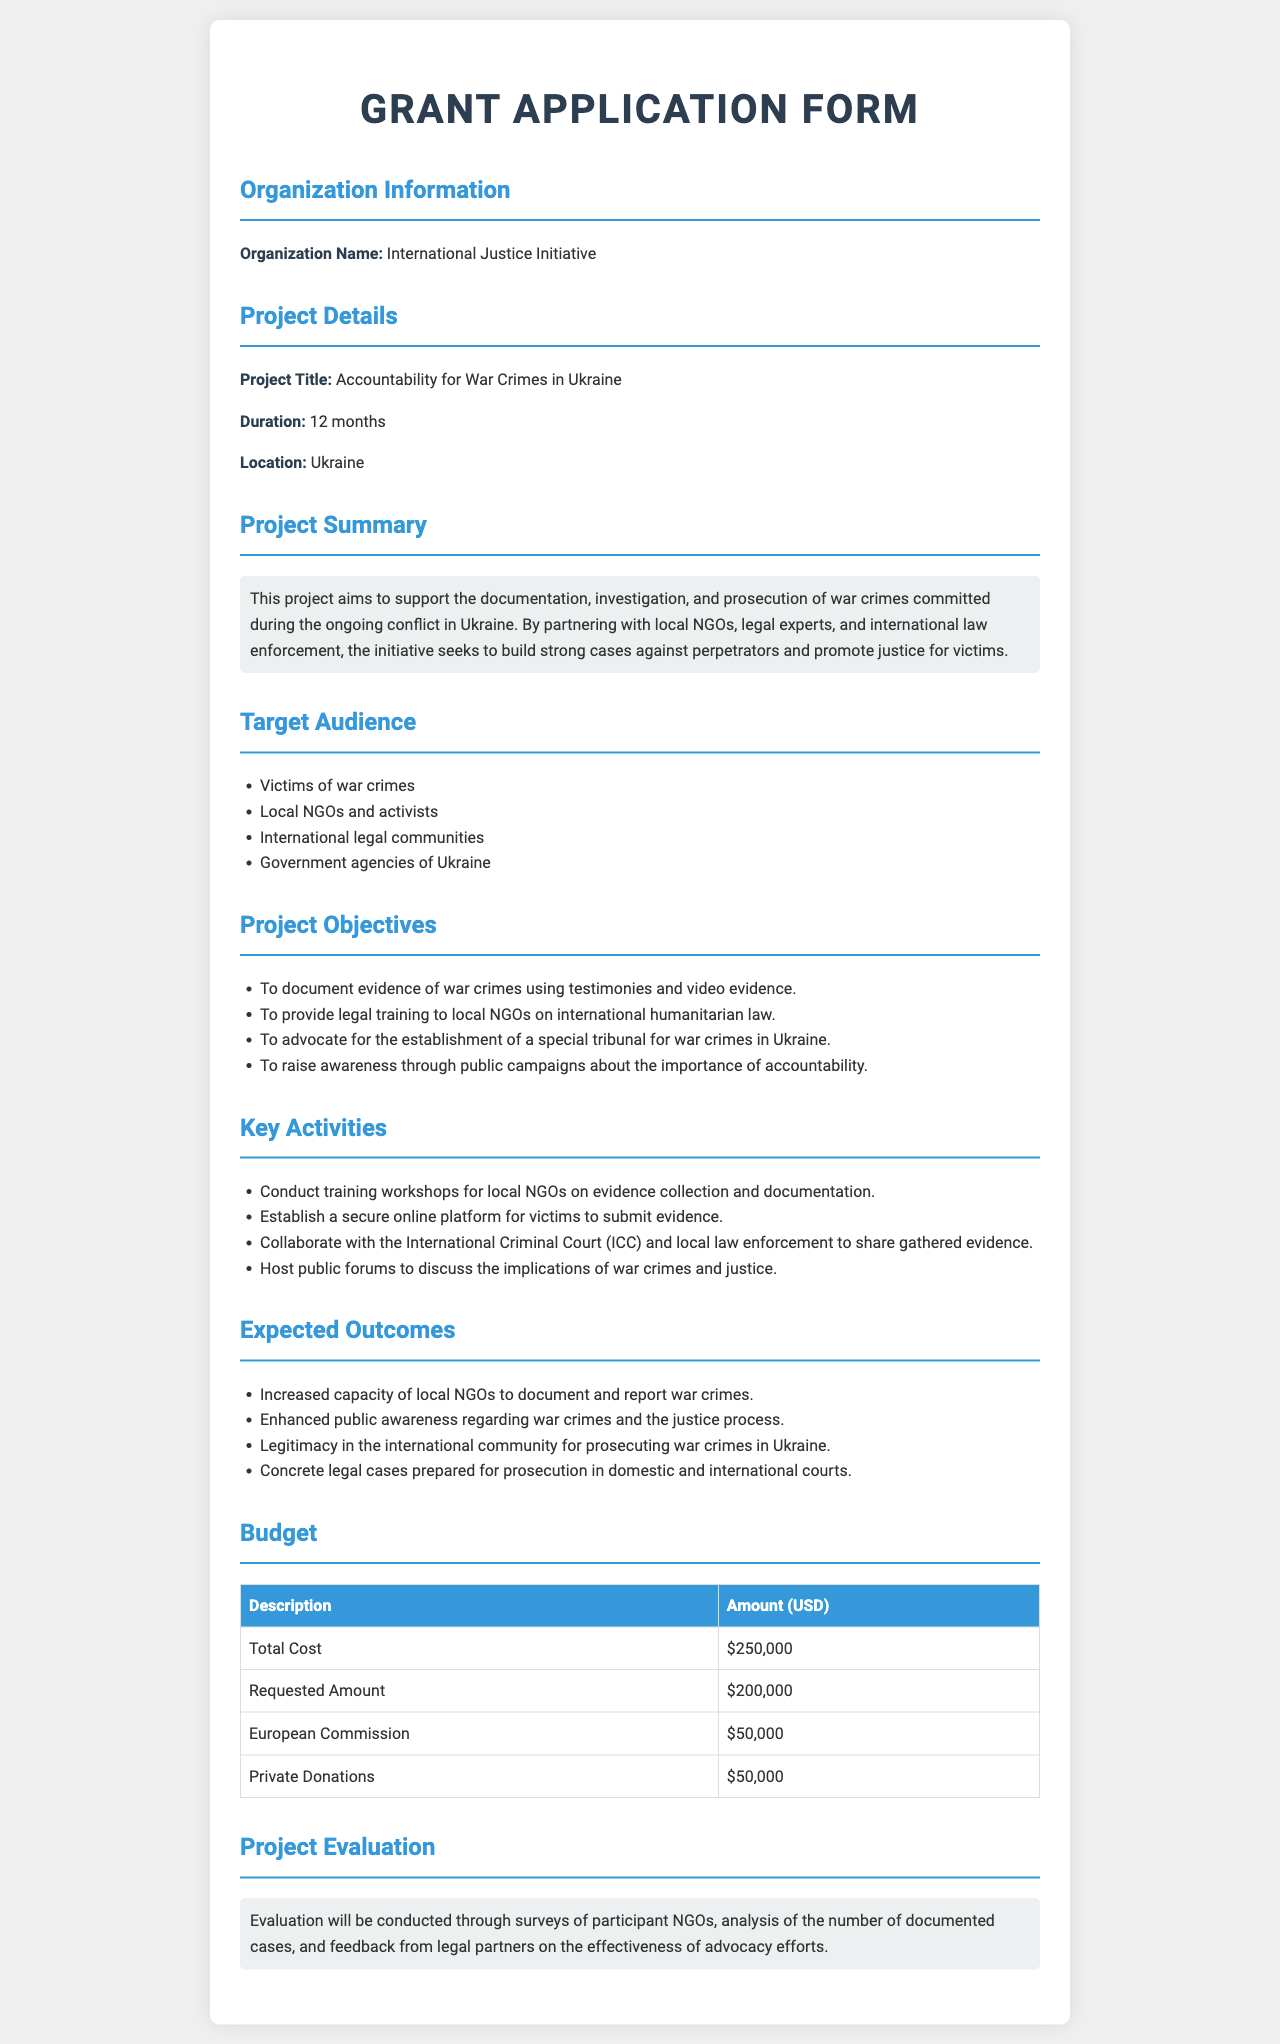What is the organization name? The organization name is stated clearly in the document under "Organization Information."
Answer: International Justice Initiative What is the project title? The project title can be found in the "Project Details" section of the document.
Answer: Accountability for War Crimes in Ukraine How long is the project duration? The project duration is specified in the "Project Details" section.
Answer: 12 months What is the total cost of the project? The total cost is detailed in the "Budget" section of the document and includes all funding sources.
Answer: $250,000 What is the requested amount for funding? The requested amount can be found in the "Budget" section and refers specifically to the amount sought from the grant.
Answer: $200,000 Who are the key activities focused on? The answer requires summarization of the activities described in the document under "Key Activities."
Answer: Local NGOs and victims What is one expected outcome of the project? Expected outcomes are listed in the "Expected Outcomes" section and highlight the project goals.
Answer: Increased capacity of local NGOs to document and report war crimes How will the project be evaluated? The evaluation methods are explained in the "Project Evaluation" section.
Answer: Surveys of participant NGOs What legal training will be provided? This information is detailed in the "Project Objectives," indicating the focus of the training.
Answer: International humanitarian law 